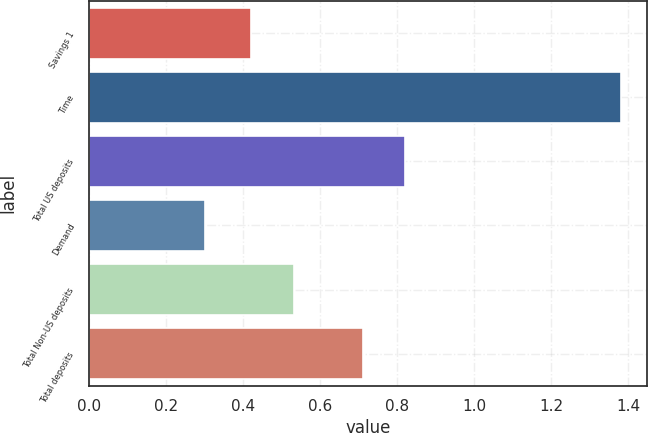Convert chart. <chart><loc_0><loc_0><loc_500><loc_500><bar_chart><fcel>Savings 1<fcel>Time<fcel>Total US deposits<fcel>Demand<fcel>Total Non-US deposits<fcel>Total deposits<nl><fcel>0.42<fcel>1.38<fcel>0.82<fcel>0.3<fcel>0.53<fcel>0.71<nl></chart> 